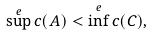<formula> <loc_0><loc_0><loc_500><loc_500>\sup ^ { e } c ( A ) < \inf ^ { e } c ( C ) ,</formula> 